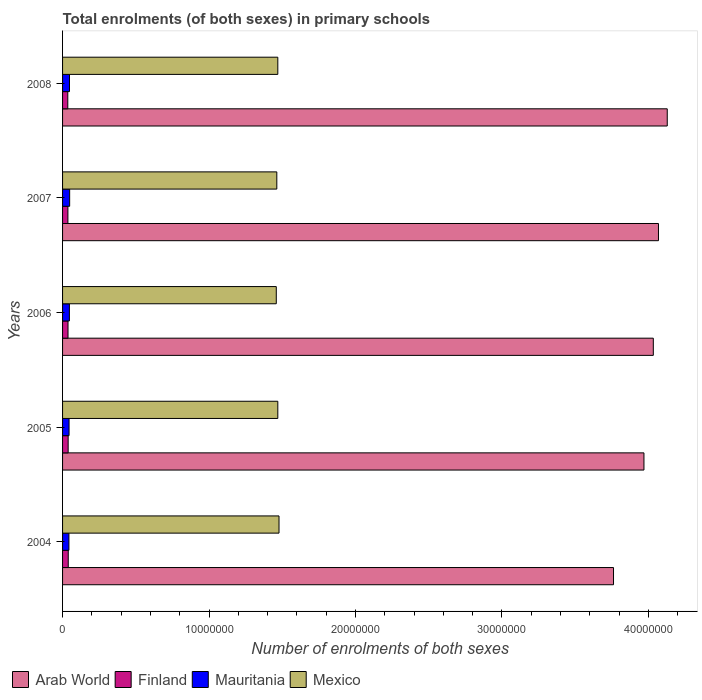How many different coloured bars are there?
Your answer should be compact. 4. Are the number of bars on each tick of the Y-axis equal?
Your answer should be very brief. Yes. In how many cases, is the number of bars for a given year not equal to the number of legend labels?
Make the answer very short. 0. What is the number of enrolments in primary schools in Arab World in 2004?
Keep it short and to the point. 3.76e+07. Across all years, what is the maximum number of enrolments in primary schools in Arab World?
Provide a short and direct response. 4.13e+07. Across all years, what is the minimum number of enrolments in primary schools in Arab World?
Your answer should be very brief. 3.76e+07. What is the total number of enrolments in primary schools in Mexico in the graph?
Provide a short and direct response. 7.34e+07. What is the difference between the number of enrolments in primary schools in Mexico in 2004 and that in 2008?
Provide a succinct answer. 8.22e+04. What is the difference between the number of enrolments in primary schools in Mauritania in 2004 and the number of enrolments in primary schools in Finland in 2005?
Provide a succinct answer. 5.24e+04. What is the average number of enrolments in primary schools in Arab World per year?
Keep it short and to the point. 3.99e+07. In the year 2006, what is the difference between the number of enrolments in primary schools in Mauritania and number of enrolments in primary schools in Arab World?
Your answer should be very brief. -3.99e+07. What is the ratio of the number of enrolments in primary schools in Mexico in 2004 to that in 2005?
Give a very brief answer. 1.01. Is the number of enrolments in primary schools in Arab World in 2007 less than that in 2008?
Provide a succinct answer. Yes. What is the difference between the highest and the second highest number of enrolments in primary schools in Mauritania?
Your answer should be very brief. 1.01e+04. What is the difference between the highest and the lowest number of enrolments in primary schools in Mexico?
Provide a succinct answer. 1.86e+05. In how many years, is the number of enrolments in primary schools in Mauritania greater than the average number of enrolments in primary schools in Mauritania taken over all years?
Offer a very short reply. 3. What does the 1st bar from the top in 2006 represents?
Ensure brevity in your answer.  Mexico. What does the 3rd bar from the bottom in 2006 represents?
Your answer should be compact. Mauritania. How many years are there in the graph?
Offer a very short reply. 5. What is the difference between two consecutive major ticks on the X-axis?
Your answer should be compact. 1.00e+07. Are the values on the major ticks of X-axis written in scientific E-notation?
Offer a very short reply. No. Does the graph contain any zero values?
Ensure brevity in your answer.  No. Does the graph contain grids?
Provide a succinct answer. No. Where does the legend appear in the graph?
Provide a short and direct response. Bottom left. How many legend labels are there?
Offer a terse response. 4. How are the legend labels stacked?
Provide a short and direct response. Horizontal. What is the title of the graph?
Keep it short and to the point. Total enrolments (of both sexes) in primary schools. Does "Gambia, The" appear as one of the legend labels in the graph?
Ensure brevity in your answer.  No. What is the label or title of the X-axis?
Give a very brief answer. Number of enrolments of both sexes. What is the label or title of the Y-axis?
Your answer should be very brief. Years. What is the Number of enrolments of both sexes of Arab World in 2004?
Your response must be concise. 3.76e+07. What is the Number of enrolments of both sexes in Finland in 2004?
Keep it short and to the point. 3.88e+05. What is the Number of enrolments of both sexes of Mauritania in 2004?
Offer a terse response. 4.34e+05. What is the Number of enrolments of both sexes in Mexico in 2004?
Ensure brevity in your answer.  1.48e+07. What is the Number of enrolments of both sexes in Arab World in 2005?
Provide a succinct answer. 3.97e+07. What is the Number of enrolments of both sexes of Finland in 2005?
Provide a succinct answer. 3.82e+05. What is the Number of enrolments of both sexes in Mauritania in 2005?
Your response must be concise. 4.44e+05. What is the Number of enrolments of both sexes of Mexico in 2005?
Offer a very short reply. 1.47e+07. What is the Number of enrolments of both sexes of Arab World in 2006?
Give a very brief answer. 4.03e+07. What is the Number of enrolments of both sexes of Finland in 2006?
Provide a succinct answer. 3.72e+05. What is the Number of enrolments of both sexes of Mauritania in 2006?
Offer a very short reply. 4.66e+05. What is the Number of enrolments of both sexes in Mexico in 2006?
Ensure brevity in your answer.  1.46e+07. What is the Number of enrolments of both sexes of Arab World in 2007?
Provide a short and direct response. 4.07e+07. What is the Number of enrolments of both sexes of Finland in 2007?
Keep it short and to the point. 3.65e+05. What is the Number of enrolments of both sexes of Mauritania in 2007?
Offer a terse response. 4.84e+05. What is the Number of enrolments of both sexes of Mexico in 2007?
Offer a terse response. 1.46e+07. What is the Number of enrolments of both sexes of Arab World in 2008?
Give a very brief answer. 4.13e+07. What is the Number of enrolments of both sexes of Finland in 2008?
Provide a short and direct response. 3.57e+05. What is the Number of enrolments of both sexes of Mauritania in 2008?
Provide a short and direct response. 4.74e+05. What is the Number of enrolments of both sexes in Mexico in 2008?
Give a very brief answer. 1.47e+07. Across all years, what is the maximum Number of enrolments of both sexes of Arab World?
Your response must be concise. 4.13e+07. Across all years, what is the maximum Number of enrolments of both sexes of Finland?
Offer a terse response. 3.88e+05. Across all years, what is the maximum Number of enrolments of both sexes of Mauritania?
Give a very brief answer. 4.84e+05. Across all years, what is the maximum Number of enrolments of both sexes in Mexico?
Offer a terse response. 1.48e+07. Across all years, what is the minimum Number of enrolments of both sexes of Arab World?
Your response must be concise. 3.76e+07. Across all years, what is the minimum Number of enrolments of both sexes of Finland?
Offer a terse response. 3.57e+05. Across all years, what is the minimum Number of enrolments of both sexes of Mauritania?
Keep it short and to the point. 4.34e+05. Across all years, what is the minimum Number of enrolments of both sexes of Mexico?
Offer a very short reply. 1.46e+07. What is the total Number of enrolments of both sexes in Arab World in the graph?
Make the answer very short. 2.00e+08. What is the total Number of enrolments of both sexes in Finland in the graph?
Your answer should be very brief. 1.86e+06. What is the total Number of enrolments of both sexes in Mauritania in the graph?
Offer a very short reply. 2.30e+06. What is the total Number of enrolments of both sexes of Mexico in the graph?
Give a very brief answer. 7.34e+07. What is the difference between the Number of enrolments of both sexes in Arab World in 2004 and that in 2005?
Offer a very short reply. -2.08e+06. What is the difference between the Number of enrolments of both sexes in Finland in 2004 and that in 2005?
Your response must be concise. 6149. What is the difference between the Number of enrolments of both sexes in Mauritania in 2004 and that in 2005?
Give a very brief answer. -9434. What is the difference between the Number of enrolments of both sexes of Mexico in 2004 and that in 2005?
Keep it short and to the point. 8.13e+04. What is the difference between the Number of enrolments of both sexes in Arab World in 2004 and that in 2006?
Provide a short and direct response. -2.72e+06. What is the difference between the Number of enrolments of both sexes of Finland in 2004 and that in 2006?
Your response must be concise. 1.58e+04. What is the difference between the Number of enrolments of both sexes in Mauritania in 2004 and that in 2006?
Keep it short and to the point. -3.18e+04. What is the difference between the Number of enrolments of both sexes in Mexico in 2004 and that in 2006?
Make the answer very short. 1.86e+05. What is the difference between the Number of enrolments of both sexes of Arab World in 2004 and that in 2007?
Your response must be concise. -3.07e+06. What is the difference between the Number of enrolments of both sexes of Finland in 2004 and that in 2007?
Provide a succinct answer. 2.30e+04. What is the difference between the Number of enrolments of both sexes of Mauritania in 2004 and that in 2007?
Ensure brevity in your answer.  -4.96e+04. What is the difference between the Number of enrolments of both sexes of Mexico in 2004 and that in 2007?
Offer a terse response. 1.50e+05. What is the difference between the Number of enrolments of both sexes of Arab World in 2004 and that in 2008?
Your answer should be compact. -3.67e+06. What is the difference between the Number of enrolments of both sexes of Finland in 2004 and that in 2008?
Offer a very short reply. 3.05e+04. What is the difference between the Number of enrolments of both sexes in Mauritania in 2004 and that in 2008?
Make the answer very short. -3.95e+04. What is the difference between the Number of enrolments of both sexes of Mexico in 2004 and that in 2008?
Keep it short and to the point. 8.22e+04. What is the difference between the Number of enrolments of both sexes in Arab World in 2005 and that in 2006?
Your response must be concise. -6.40e+05. What is the difference between the Number of enrolments of both sexes in Finland in 2005 and that in 2006?
Provide a short and direct response. 9657. What is the difference between the Number of enrolments of both sexes of Mauritania in 2005 and that in 2006?
Your response must be concise. -2.24e+04. What is the difference between the Number of enrolments of both sexes of Mexico in 2005 and that in 2006?
Provide a short and direct response. 1.05e+05. What is the difference between the Number of enrolments of both sexes of Arab World in 2005 and that in 2007?
Provide a short and direct response. -9.92e+05. What is the difference between the Number of enrolments of both sexes of Finland in 2005 and that in 2007?
Offer a terse response. 1.69e+04. What is the difference between the Number of enrolments of both sexes in Mauritania in 2005 and that in 2007?
Keep it short and to the point. -4.02e+04. What is the difference between the Number of enrolments of both sexes of Mexico in 2005 and that in 2007?
Offer a terse response. 6.85e+04. What is the difference between the Number of enrolments of both sexes in Arab World in 2005 and that in 2008?
Offer a terse response. -1.59e+06. What is the difference between the Number of enrolments of both sexes in Finland in 2005 and that in 2008?
Provide a short and direct response. 2.44e+04. What is the difference between the Number of enrolments of both sexes in Mauritania in 2005 and that in 2008?
Provide a succinct answer. -3.01e+04. What is the difference between the Number of enrolments of both sexes of Mexico in 2005 and that in 2008?
Offer a terse response. 859. What is the difference between the Number of enrolments of both sexes in Arab World in 2006 and that in 2007?
Ensure brevity in your answer.  -3.53e+05. What is the difference between the Number of enrolments of both sexes of Finland in 2006 and that in 2007?
Keep it short and to the point. 7226. What is the difference between the Number of enrolments of both sexes in Mauritania in 2006 and that in 2007?
Keep it short and to the point. -1.78e+04. What is the difference between the Number of enrolments of both sexes of Mexico in 2006 and that in 2007?
Offer a very short reply. -3.63e+04. What is the difference between the Number of enrolments of both sexes of Arab World in 2006 and that in 2008?
Offer a very short reply. -9.52e+05. What is the difference between the Number of enrolments of both sexes in Finland in 2006 and that in 2008?
Provide a succinct answer. 1.47e+04. What is the difference between the Number of enrolments of both sexes in Mauritania in 2006 and that in 2008?
Give a very brief answer. -7718. What is the difference between the Number of enrolments of both sexes of Mexico in 2006 and that in 2008?
Give a very brief answer. -1.04e+05. What is the difference between the Number of enrolments of both sexes in Arab World in 2007 and that in 2008?
Give a very brief answer. -6.00e+05. What is the difference between the Number of enrolments of both sexes in Finland in 2007 and that in 2008?
Your answer should be very brief. 7499. What is the difference between the Number of enrolments of both sexes in Mauritania in 2007 and that in 2008?
Provide a succinct answer. 1.01e+04. What is the difference between the Number of enrolments of both sexes of Mexico in 2007 and that in 2008?
Keep it short and to the point. -6.76e+04. What is the difference between the Number of enrolments of both sexes of Arab World in 2004 and the Number of enrolments of both sexes of Finland in 2005?
Give a very brief answer. 3.72e+07. What is the difference between the Number of enrolments of both sexes in Arab World in 2004 and the Number of enrolments of both sexes in Mauritania in 2005?
Your answer should be compact. 3.72e+07. What is the difference between the Number of enrolments of both sexes in Arab World in 2004 and the Number of enrolments of both sexes in Mexico in 2005?
Your response must be concise. 2.29e+07. What is the difference between the Number of enrolments of both sexes of Finland in 2004 and the Number of enrolments of both sexes of Mauritania in 2005?
Provide a short and direct response. -5.57e+04. What is the difference between the Number of enrolments of both sexes in Finland in 2004 and the Number of enrolments of both sexes in Mexico in 2005?
Your answer should be compact. -1.43e+07. What is the difference between the Number of enrolments of both sexes in Mauritania in 2004 and the Number of enrolments of both sexes in Mexico in 2005?
Your answer should be compact. -1.43e+07. What is the difference between the Number of enrolments of both sexes in Arab World in 2004 and the Number of enrolments of both sexes in Finland in 2006?
Offer a very short reply. 3.73e+07. What is the difference between the Number of enrolments of both sexes in Arab World in 2004 and the Number of enrolments of both sexes in Mauritania in 2006?
Make the answer very short. 3.72e+07. What is the difference between the Number of enrolments of both sexes of Arab World in 2004 and the Number of enrolments of both sexes of Mexico in 2006?
Provide a short and direct response. 2.30e+07. What is the difference between the Number of enrolments of both sexes of Finland in 2004 and the Number of enrolments of both sexes of Mauritania in 2006?
Your answer should be compact. -7.80e+04. What is the difference between the Number of enrolments of both sexes of Finland in 2004 and the Number of enrolments of both sexes of Mexico in 2006?
Your answer should be very brief. -1.42e+07. What is the difference between the Number of enrolments of both sexes in Mauritania in 2004 and the Number of enrolments of both sexes in Mexico in 2006?
Your answer should be compact. -1.42e+07. What is the difference between the Number of enrolments of both sexes of Arab World in 2004 and the Number of enrolments of both sexes of Finland in 2007?
Offer a very short reply. 3.73e+07. What is the difference between the Number of enrolments of both sexes in Arab World in 2004 and the Number of enrolments of both sexes in Mauritania in 2007?
Ensure brevity in your answer.  3.71e+07. What is the difference between the Number of enrolments of both sexes in Arab World in 2004 and the Number of enrolments of both sexes in Mexico in 2007?
Offer a terse response. 2.30e+07. What is the difference between the Number of enrolments of both sexes of Finland in 2004 and the Number of enrolments of both sexes of Mauritania in 2007?
Offer a very short reply. -9.58e+04. What is the difference between the Number of enrolments of both sexes of Finland in 2004 and the Number of enrolments of both sexes of Mexico in 2007?
Give a very brief answer. -1.42e+07. What is the difference between the Number of enrolments of both sexes of Mauritania in 2004 and the Number of enrolments of both sexes of Mexico in 2007?
Ensure brevity in your answer.  -1.42e+07. What is the difference between the Number of enrolments of both sexes of Arab World in 2004 and the Number of enrolments of both sexes of Finland in 2008?
Ensure brevity in your answer.  3.73e+07. What is the difference between the Number of enrolments of both sexes of Arab World in 2004 and the Number of enrolments of both sexes of Mauritania in 2008?
Provide a short and direct response. 3.72e+07. What is the difference between the Number of enrolments of both sexes of Arab World in 2004 and the Number of enrolments of both sexes of Mexico in 2008?
Your response must be concise. 2.29e+07. What is the difference between the Number of enrolments of both sexes in Finland in 2004 and the Number of enrolments of both sexes in Mauritania in 2008?
Provide a succinct answer. -8.58e+04. What is the difference between the Number of enrolments of both sexes in Finland in 2004 and the Number of enrolments of both sexes in Mexico in 2008?
Give a very brief answer. -1.43e+07. What is the difference between the Number of enrolments of both sexes in Mauritania in 2004 and the Number of enrolments of both sexes in Mexico in 2008?
Your response must be concise. -1.43e+07. What is the difference between the Number of enrolments of both sexes in Arab World in 2005 and the Number of enrolments of both sexes in Finland in 2006?
Ensure brevity in your answer.  3.93e+07. What is the difference between the Number of enrolments of both sexes in Arab World in 2005 and the Number of enrolments of both sexes in Mauritania in 2006?
Your response must be concise. 3.92e+07. What is the difference between the Number of enrolments of both sexes in Arab World in 2005 and the Number of enrolments of both sexes in Mexico in 2006?
Your response must be concise. 2.51e+07. What is the difference between the Number of enrolments of both sexes in Finland in 2005 and the Number of enrolments of both sexes in Mauritania in 2006?
Offer a very short reply. -8.42e+04. What is the difference between the Number of enrolments of both sexes of Finland in 2005 and the Number of enrolments of both sexes of Mexico in 2006?
Offer a very short reply. -1.42e+07. What is the difference between the Number of enrolments of both sexes of Mauritania in 2005 and the Number of enrolments of both sexes of Mexico in 2006?
Your answer should be very brief. -1.42e+07. What is the difference between the Number of enrolments of both sexes in Arab World in 2005 and the Number of enrolments of both sexes in Finland in 2007?
Offer a terse response. 3.93e+07. What is the difference between the Number of enrolments of both sexes of Arab World in 2005 and the Number of enrolments of both sexes of Mauritania in 2007?
Offer a terse response. 3.92e+07. What is the difference between the Number of enrolments of both sexes of Arab World in 2005 and the Number of enrolments of both sexes of Mexico in 2007?
Your answer should be compact. 2.51e+07. What is the difference between the Number of enrolments of both sexes in Finland in 2005 and the Number of enrolments of both sexes in Mauritania in 2007?
Provide a short and direct response. -1.02e+05. What is the difference between the Number of enrolments of both sexes in Finland in 2005 and the Number of enrolments of both sexes in Mexico in 2007?
Ensure brevity in your answer.  -1.42e+07. What is the difference between the Number of enrolments of both sexes in Mauritania in 2005 and the Number of enrolments of both sexes in Mexico in 2007?
Make the answer very short. -1.42e+07. What is the difference between the Number of enrolments of both sexes in Arab World in 2005 and the Number of enrolments of both sexes in Finland in 2008?
Offer a very short reply. 3.93e+07. What is the difference between the Number of enrolments of both sexes in Arab World in 2005 and the Number of enrolments of both sexes in Mauritania in 2008?
Provide a short and direct response. 3.92e+07. What is the difference between the Number of enrolments of both sexes of Arab World in 2005 and the Number of enrolments of both sexes of Mexico in 2008?
Your answer should be compact. 2.50e+07. What is the difference between the Number of enrolments of both sexes in Finland in 2005 and the Number of enrolments of both sexes in Mauritania in 2008?
Keep it short and to the point. -9.19e+04. What is the difference between the Number of enrolments of both sexes in Finland in 2005 and the Number of enrolments of both sexes in Mexico in 2008?
Make the answer very short. -1.43e+07. What is the difference between the Number of enrolments of both sexes of Mauritania in 2005 and the Number of enrolments of both sexes of Mexico in 2008?
Provide a short and direct response. -1.43e+07. What is the difference between the Number of enrolments of both sexes in Arab World in 2006 and the Number of enrolments of both sexes in Finland in 2007?
Offer a very short reply. 4.00e+07. What is the difference between the Number of enrolments of both sexes in Arab World in 2006 and the Number of enrolments of both sexes in Mauritania in 2007?
Offer a terse response. 3.99e+07. What is the difference between the Number of enrolments of both sexes of Arab World in 2006 and the Number of enrolments of both sexes of Mexico in 2007?
Provide a succinct answer. 2.57e+07. What is the difference between the Number of enrolments of both sexes of Finland in 2006 and the Number of enrolments of both sexes of Mauritania in 2007?
Ensure brevity in your answer.  -1.12e+05. What is the difference between the Number of enrolments of both sexes in Finland in 2006 and the Number of enrolments of both sexes in Mexico in 2007?
Offer a very short reply. -1.43e+07. What is the difference between the Number of enrolments of both sexes in Mauritania in 2006 and the Number of enrolments of both sexes in Mexico in 2007?
Offer a terse response. -1.42e+07. What is the difference between the Number of enrolments of both sexes of Arab World in 2006 and the Number of enrolments of both sexes of Finland in 2008?
Offer a terse response. 4.00e+07. What is the difference between the Number of enrolments of both sexes of Arab World in 2006 and the Number of enrolments of both sexes of Mauritania in 2008?
Offer a terse response. 3.99e+07. What is the difference between the Number of enrolments of both sexes in Arab World in 2006 and the Number of enrolments of both sexes in Mexico in 2008?
Your answer should be compact. 2.56e+07. What is the difference between the Number of enrolments of both sexes of Finland in 2006 and the Number of enrolments of both sexes of Mauritania in 2008?
Give a very brief answer. -1.02e+05. What is the difference between the Number of enrolments of both sexes in Finland in 2006 and the Number of enrolments of both sexes in Mexico in 2008?
Your answer should be very brief. -1.43e+07. What is the difference between the Number of enrolments of both sexes in Mauritania in 2006 and the Number of enrolments of both sexes in Mexico in 2008?
Keep it short and to the point. -1.42e+07. What is the difference between the Number of enrolments of both sexes of Arab World in 2007 and the Number of enrolments of both sexes of Finland in 2008?
Offer a terse response. 4.03e+07. What is the difference between the Number of enrolments of both sexes in Arab World in 2007 and the Number of enrolments of both sexes in Mauritania in 2008?
Your answer should be compact. 4.02e+07. What is the difference between the Number of enrolments of both sexes of Arab World in 2007 and the Number of enrolments of both sexes of Mexico in 2008?
Offer a terse response. 2.60e+07. What is the difference between the Number of enrolments of both sexes in Finland in 2007 and the Number of enrolments of both sexes in Mauritania in 2008?
Offer a very short reply. -1.09e+05. What is the difference between the Number of enrolments of both sexes of Finland in 2007 and the Number of enrolments of both sexes of Mexico in 2008?
Provide a succinct answer. -1.43e+07. What is the difference between the Number of enrolments of both sexes in Mauritania in 2007 and the Number of enrolments of both sexes in Mexico in 2008?
Your response must be concise. -1.42e+07. What is the average Number of enrolments of both sexes of Arab World per year?
Keep it short and to the point. 3.99e+07. What is the average Number of enrolments of both sexes of Finland per year?
Give a very brief answer. 3.73e+05. What is the average Number of enrolments of both sexes in Mauritania per year?
Make the answer very short. 4.60e+05. What is the average Number of enrolments of both sexes in Mexico per year?
Make the answer very short. 1.47e+07. In the year 2004, what is the difference between the Number of enrolments of both sexes of Arab World and Number of enrolments of both sexes of Finland?
Your answer should be very brief. 3.72e+07. In the year 2004, what is the difference between the Number of enrolments of both sexes of Arab World and Number of enrolments of both sexes of Mauritania?
Your response must be concise. 3.72e+07. In the year 2004, what is the difference between the Number of enrolments of both sexes in Arab World and Number of enrolments of both sexes in Mexico?
Give a very brief answer. 2.28e+07. In the year 2004, what is the difference between the Number of enrolments of both sexes in Finland and Number of enrolments of both sexes in Mauritania?
Offer a terse response. -4.62e+04. In the year 2004, what is the difference between the Number of enrolments of both sexes in Finland and Number of enrolments of both sexes in Mexico?
Offer a very short reply. -1.44e+07. In the year 2004, what is the difference between the Number of enrolments of both sexes in Mauritania and Number of enrolments of both sexes in Mexico?
Provide a short and direct response. -1.43e+07. In the year 2005, what is the difference between the Number of enrolments of both sexes in Arab World and Number of enrolments of both sexes in Finland?
Keep it short and to the point. 3.93e+07. In the year 2005, what is the difference between the Number of enrolments of both sexes in Arab World and Number of enrolments of both sexes in Mauritania?
Offer a very short reply. 3.93e+07. In the year 2005, what is the difference between the Number of enrolments of both sexes of Arab World and Number of enrolments of both sexes of Mexico?
Keep it short and to the point. 2.50e+07. In the year 2005, what is the difference between the Number of enrolments of both sexes of Finland and Number of enrolments of both sexes of Mauritania?
Provide a succinct answer. -6.18e+04. In the year 2005, what is the difference between the Number of enrolments of both sexes in Finland and Number of enrolments of both sexes in Mexico?
Make the answer very short. -1.43e+07. In the year 2005, what is the difference between the Number of enrolments of both sexes of Mauritania and Number of enrolments of both sexes of Mexico?
Offer a terse response. -1.43e+07. In the year 2006, what is the difference between the Number of enrolments of both sexes of Arab World and Number of enrolments of both sexes of Finland?
Your answer should be compact. 4.00e+07. In the year 2006, what is the difference between the Number of enrolments of both sexes of Arab World and Number of enrolments of both sexes of Mauritania?
Ensure brevity in your answer.  3.99e+07. In the year 2006, what is the difference between the Number of enrolments of both sexes in Arab World and Number of enrolments of both sexes in Mexico?
Offer a terse response. 2.57e+07. In the year 2006, what is the difference between the Number of enrolments of both sexes in Finland and Number of enrolments of both sexes in Mauritania?
Provide a short and direct response. -9.38e+04. In the year 2006, what is the difference between the Number of enrolments of both sexes in Finland and Number of enrolments of both sexes in Mexico?
Your response must be concise. -1.42e+07. In the year 2006, what is the difference between the Number of enrolments of both sexes of Mauritania and Number of enrolments of both sexes of Mexico?
Keep it short and to the point. -1.41e+07. In the year 2007, what is the difference between the Number of enrolments of both sexes in Arab World and Number of enrolments of both sexes in Finland?
Your response must be concise. 4.03e+07. In the year 2007, what is the difference between the Number of enrolments of both sexes in Arab World and Number of enrolments of both sexes in Mauritania?
Give a very brief answer. 4.02e+07. In the year 2007, what is the difference between the Number of enrolments of both sexes of Arab World and Number of enrolments of both sexes of Mexico?
Provide a short and direct response. 2.61e+07. In the year 2007, what is the difference between the Number of enrolments of both sexes of Finland and Number of enrolments of both sexes of Mauritania?
Provide a succinct answer. -1.19e+05. In the year 2007, what is the difference between the Number of enrolments of both sexes in Finland and Number of enrolments of both sexes in Mexico?
Give a very brief answer. -1.43e+07. In the year 2007, what is the difference between the Number of enrolments of both sexes of Mauritania and Number of enrolments of both sexes of Mexico?
Keep it short and to the point. -1.41e+07. In the year 2008, what is the difference between the Number of enrolments of both sexes of Arab World and Number of enrolments of both sexes of Finland?
Your response must be concise. 4.09e+07. In the year 2008, what is the difference between the Number of enrolments of both sexes in Arab World and Number of enrolments of both sexes in Mauritania?
Offer a terse response. 4.08e+07. In the year 2008, what is the difference between the Number of enrolments of both sexes in Arab World and Number of enrolments of both sexes in Mexico?
Provide a short and direct response. 2.66e+07. In the year 2008, what is the difference between the Number of enrolments of both sexes of Finland and Number of enrolments of both sexes of Mauritania?
Provide a succinct answer. -1.16e+05. In the year 2008, what is the difference between the Number of enrolments of both sexes in Finland and Number of enrolments of both sexes in Mexico?
Your answer should be compact. -1.43e+07. In the year 2008, what is the difference between the Number of enrolments of both sexes in Mauritania and Number of enrolments of both sexes in Mexico?
Give a very brief answer. -1.42e+07. What is the ratio of the Number of enrolments of both sexes of Arab World in 2004 to that in 2005?
Offer a terse response. 0.95. What is the ratio of the Number of enrolments of both sexes in Finland in 2004 to that in 2005?
Offer a very short reply. 1.02. What is the ratio of the Number of enrolments of both sexes in Mauritania in 2004 to that in 2005?
Your answer should be compact. 0.98. What is the ratio of the Number of enrolments of both sexes of Arab World in 2004 to that in 2006?
Offer a very short reply. 0.93. What is the ratio of the Number of enrolments of both sexes in Finland in 2004 to that in 2006?
Your response must be concise. 1.04. What is the ratio of the Number of enrolments of both sexes in Mauritania in 2004 to that in 2006?
Offer a terse response. 0.93. What is the ratio of the Number of enrolments of both sexes of Mexico in 2004 to that in 2006?
Offer a very short reply. 1.01. What is the ratio of the Number of enrolments of both sexes in Arab World in 2004 to that in 2007?
Ensure brevity in your answer.  0.92. What is the ratio of the Number of enrolments of both sexes in Finland in 2004 to that in 2007?
Provide a short and direct response. 1.06. What is the ratio of the Number of enrolments of both sexes in Mauritania in 2004 to that in 2007?
Your response must be concise. 0.9. What is the ratio of the Number of enrolments of both sexes in Mexico in 2004 to that in 2007?
Provide a short and direct response. 1.01. What is the ratio of the Number of enrolments of both sexes in Arab World in 2004 to that in 2008?
Make the answer very short. 0.91. What is the ratio of the Number of enrolments of both sexes in Finland in 2004 to that in 2008?
Your answer should be compact. 1.09. What is the ratio of the Number of enrolments of both sexes in Mauritania in 2004 to that in 2008?
Offer a terse response. 0.92. What is the ratio of the Number of enrolments of both sexes of Mexico in 2004 to that in 2008?
Ensure brevity in your answer.  1.01. What is the ratio of the Number of enrolments of both sexes in Arab World in 2005 to that in 2006?
Keep it short and to the point. 0.98. What is the ratio of the Number of enrolments of both sexes in Mexico in 2005 to that in 2006?
Give a very brief answer. 1.01. What is the ratio of the Number of enrolments of both sexes of Arab World in 2005 to that in 2007?
Give a very brief answer. 0.98. What is the ratio of the Number of enrolments of both sexes of Finland in 2005 to that in 2007?
Your answer should be compact. 1.05. What is the ratio of the Number of enrolments of both sexes in Mauritania in 2005 to that in 2007?
Offer a very short reply. 0.92. What is the ratio of the Number of enrolments of both sexes in Mexico in 2005 to that in 2007?
Ensure brevity in your answer.  1. What is the ratio of the Number of enrolments of both sexes of Arab World in 2005 to that in 2008?
Your response must be concise. 0.96. What is the ratio of the Number of enrolments of both sexes of Finland in 2005 to that in 2008?
Your answer should be very brief. 1.07. What is the ratio of the Number of enrolments of both sexes in Mauritania in 2005 to that in 2008?
Provide a succinct answer. 0.94. What is the ratio of the Number of enrolments of both sexes in Mexico in 2005 to that in 2008?
Ensure brevity in your answer.  1. What is the ratio of the Number of enrolments of both sexes in Finland in 2006 to that in 2007?
Give a very brief answer. 1.02. What is the ratio of the Number of enrolments of both sexes of Mauritania in 2006 to that in 2007?
Keep it short and to the point. 0.96. What is the ratio of the Number of enrolments of both sexes in Mexico in 2006 to that in 2007?
Offer a terse response. 1. What is the ratio of the Number of enrolments of both sexes in Arab World in 2006 to that in 2008?
Provide a succinct answer. 0.98. What is the ratio of the Number of enrolments of both sexes of Finland in 2006 to that in 2008?
Provide a short and direct response. 1.04. What is the ratio of the Number of enrolments of both sexes in Mauritania in 2006 to that in 2008?
Keep it short and to the point. 0.98. What is the ratio of the Number of enrolments of both sexes of Arab World in 2007 to that in 2008?
Keep it short and to the point. 0.99. What is the ratio of the Number of enrolments of both sexes in Finland in 2007 to that in 2008?
Make the answer very short. 1.02. What is the ratio of the Number of enrolments of both sexes in Mauritania in 2007 to that in 2008?
Your answer should be compact. 1.02. What is the difference between the highest and the second highest Number of enrolments of both sexes in Arab World?
Keep it short and to the point. 6.00e+05. What is the difference between the highest and the second highest Number of enrolments of both sexes of Finland?
Your response must be concise. 6149. What is the difference between the highest and the second highest Number of enrolments of both sexes of Mauritania?
Your response must be concise. 1.01e+04. What is the difference between the highest and the second highest Number of enrolments of both sexes in Mexico?
Offer a terse response. 8.13e+04. What is the difference between the highest and the lowest Number of enrolments of both sexes of Arab World?
Keep it short and to the point. 3.67e+06. What is the difference between the highest and the lowest Number of enrolments of both sexes in Finland?
Your answer should be compact. 3.05e+04. What is the difference between the highest and the lowest Number of enrolments of both sexes in Mauritania?
Your answer should be very brief. 4.96e+04. What is the difference between the highest and the lowest Number of enrolments of both sexes in Mexico?
Your answer should be compact. 1.86e+05. 